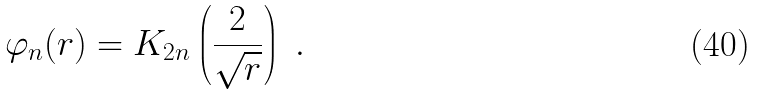Convert formula to latex. <formula><loc_0><loc_0><loc_500><loc_500>\varphi _ { n } ( r ) = K _ { 2 n } \left ( \frac { 2 } { \sqrt { r } } \right ) \ .</formula> 